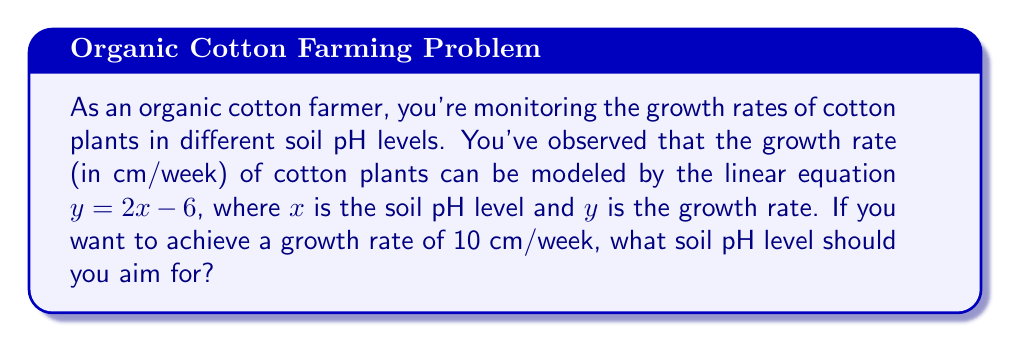Can you answer this question? To solve this problem, we need to use the given linear equation and substitute the desired growth rate. Then, we'll solve for the pH level.

1) The given linear equation is:
   $y = 2x - 6$

2) We want to find $x$ when $y = 10$ cm/week. Let's substitute this:
   $10 = 2x - 6$

3) Now, let's solve for $x$:
   $10 + 6 = 2x$
   $16 = 2x$

4) Divide both sides by 2:
   $\frac{16}{2} = \frac{2x}{2}$
   $8 = x$

5) Therefore, the soil pH level should be 8 to achieve a growth rate of 10 cm/week.

It's worth noting that a pH of 8 is slightly alkaline. In practice, cotton typically prefers slightly acidic to neutral soil (pH 5.8-7), so this theoretical optimal pH for maximum growth might not be ideal for overall plant health and yield in real-world conditions.
Answer: $x = 8$
The ideal soil pH level to achieve a growth rate of 10 cm/week is 8. 